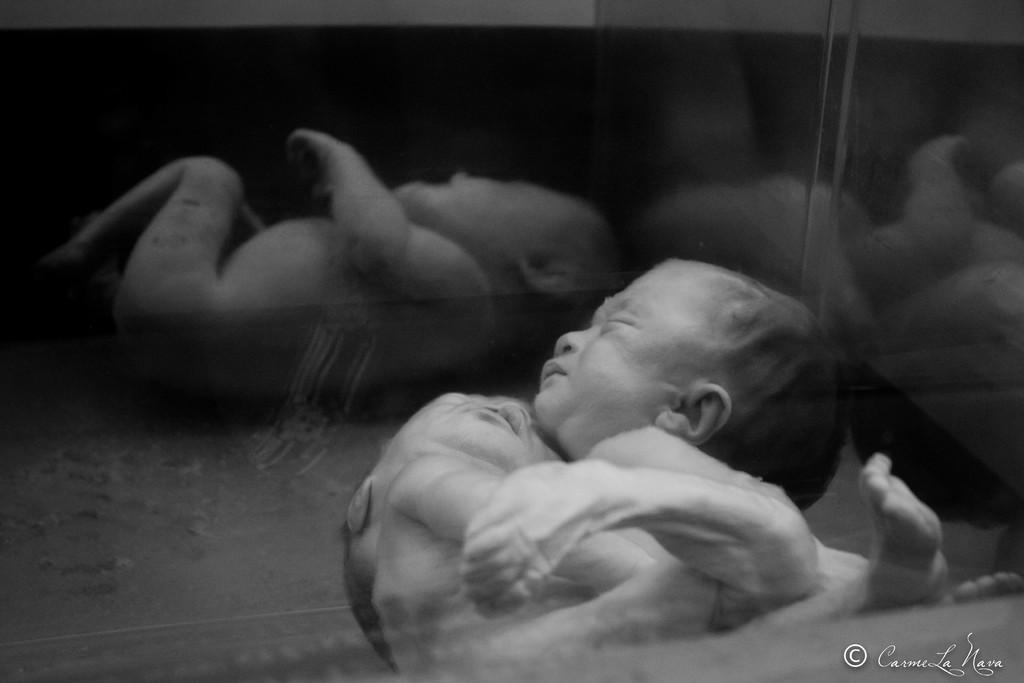What is the main subject of the image? There is a baby in the image. What object is also visible in the image? There is a glass in the image. What can be seen in the reflection of the glass? The glass contains the reflection of the baby. What type of desk is visible in the image? There is no desk present in the image. How does the carriage help the baby in the image? There is no carriage present in the image, so it cannot help the baby. 